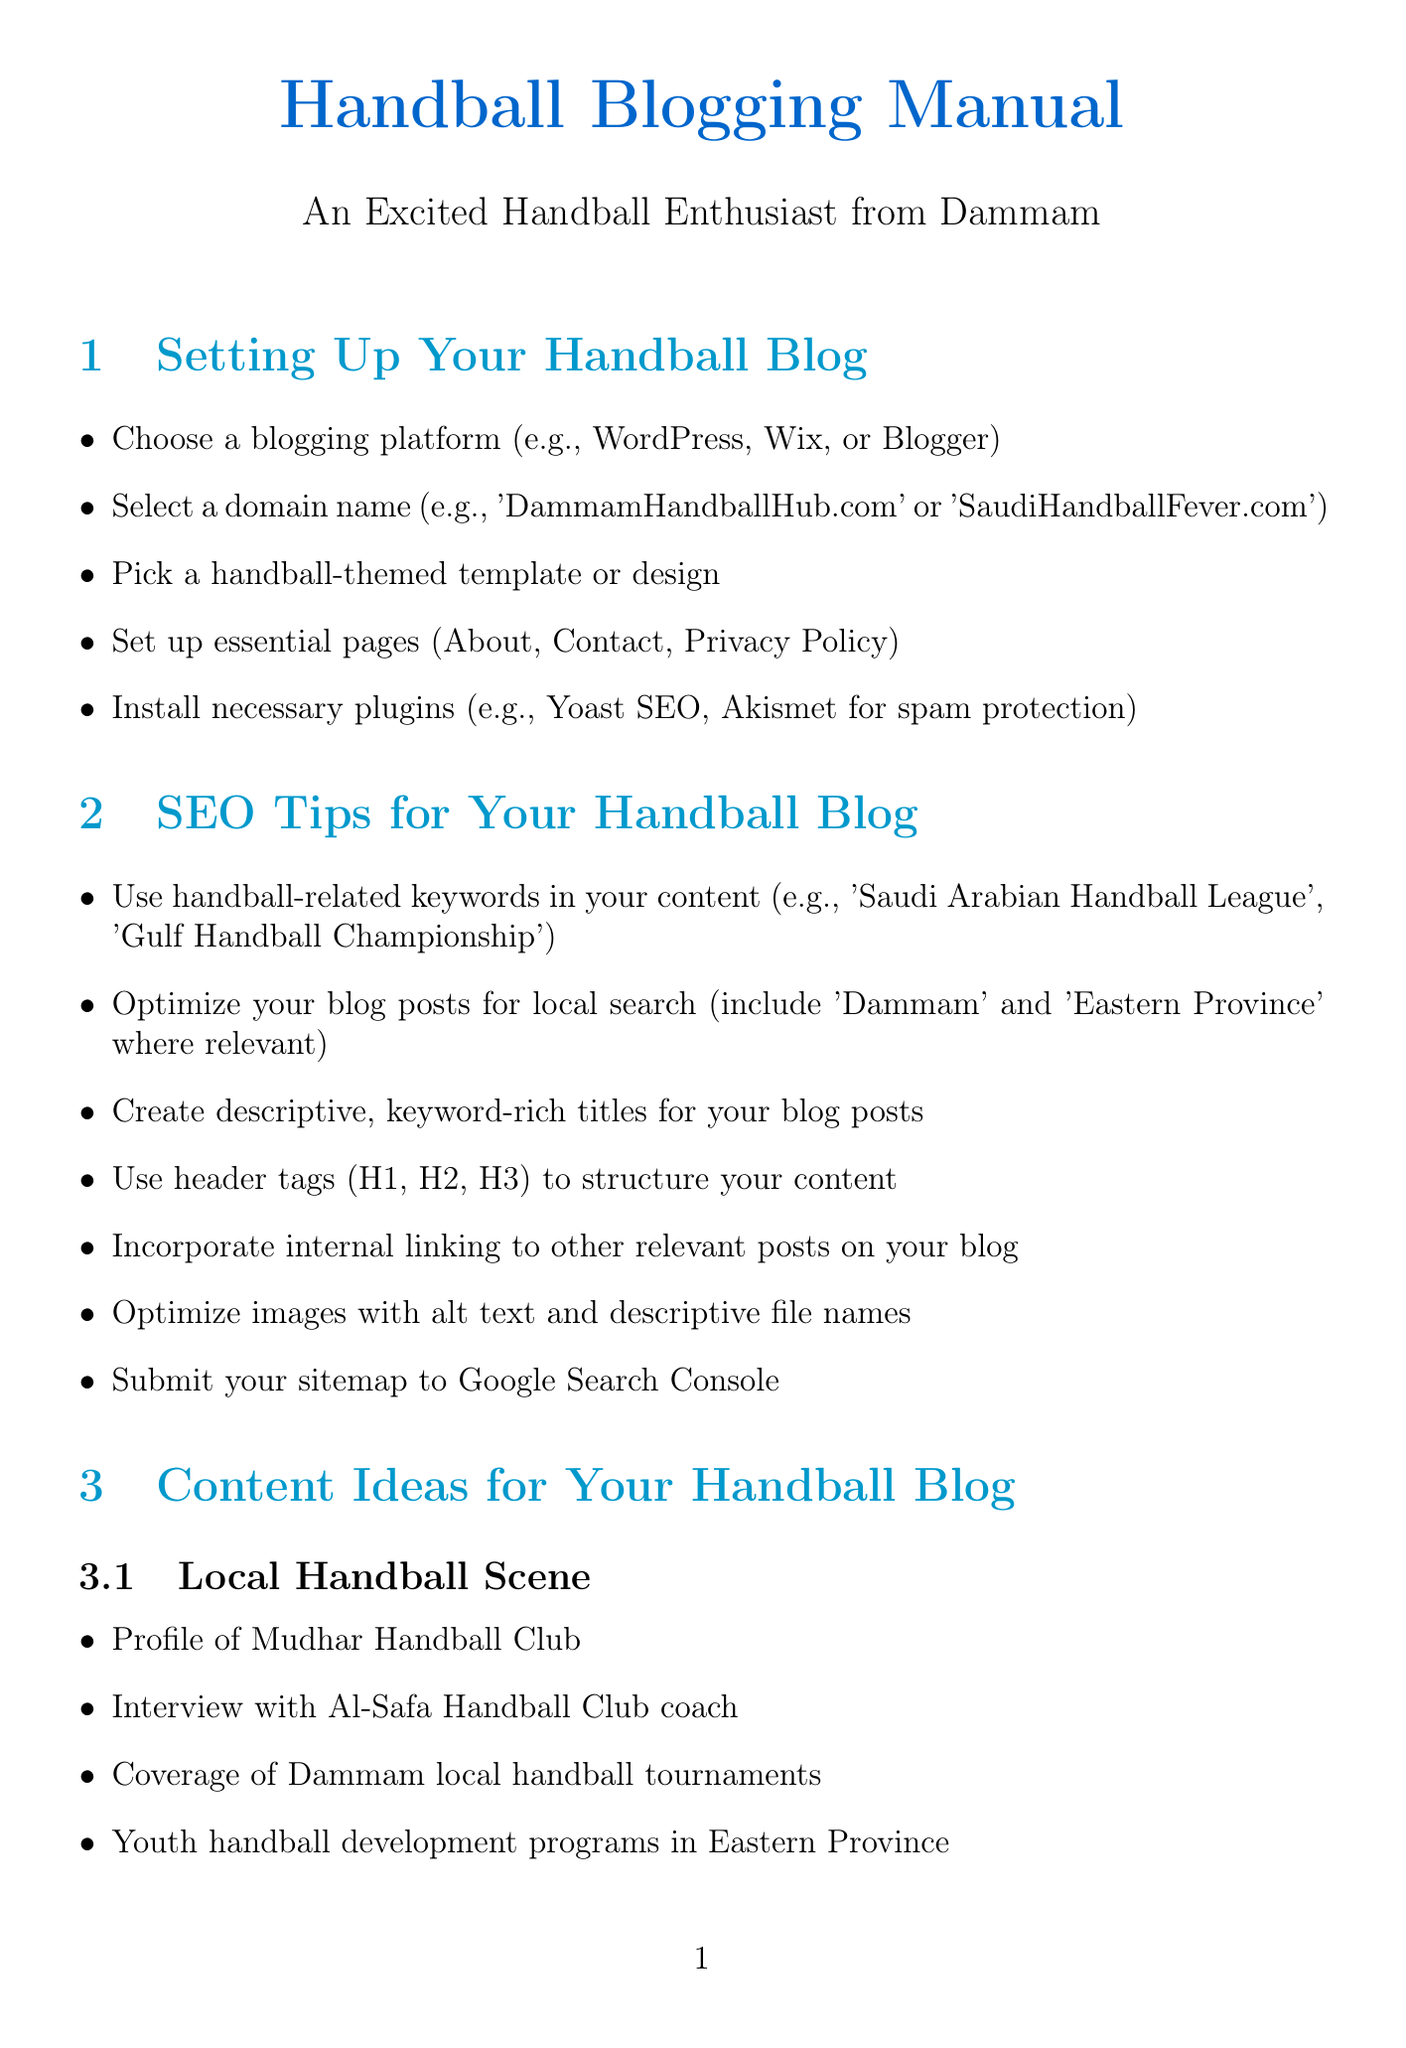What are recommended blogging platforms? The document lists WordPress, Wix, or Blogger as recommended blogging platforms for setting up your handball blog.
Answer: WordPress, Wix, Blogger What pages should you set up on your blog? The document specifies essential pages to set up: About, Contact, and Privacy Policy.
Answer: About, Contact, Privacy Policy Which keyword example is suggested for SEO? The document provides 'Saudi Arabian Handball League' as a handball-related keyword example for SEO optimization.
Answer: Saudi Arabian Handball League How many content ideas are listed for the Local Handball Scene? The document provides four specific content ideas for the Local Handball Scene.
Answer: Four What is one way to engage your audience? The document suggests hosting Q&A sessions with local handball players as a strategy for engaging the audience.
Answer: Host Q&A sessions Name one method for monetizing your blog. The document mentions partnering with local handball equipment suppliers for affiliate marketing as a monetization method.
Answer: Affiliate marketing What is an effective way to promote your blog on Instagram? Sharing action shots from local handball games is mentioned as an effective promotion tip on Instagram.
Answer: Share action shots What type of content is recommended for YouTube? The document suggests uploading handball tutorial videos as a type of content for YouTube.
Answer: Handball tutorial videos 